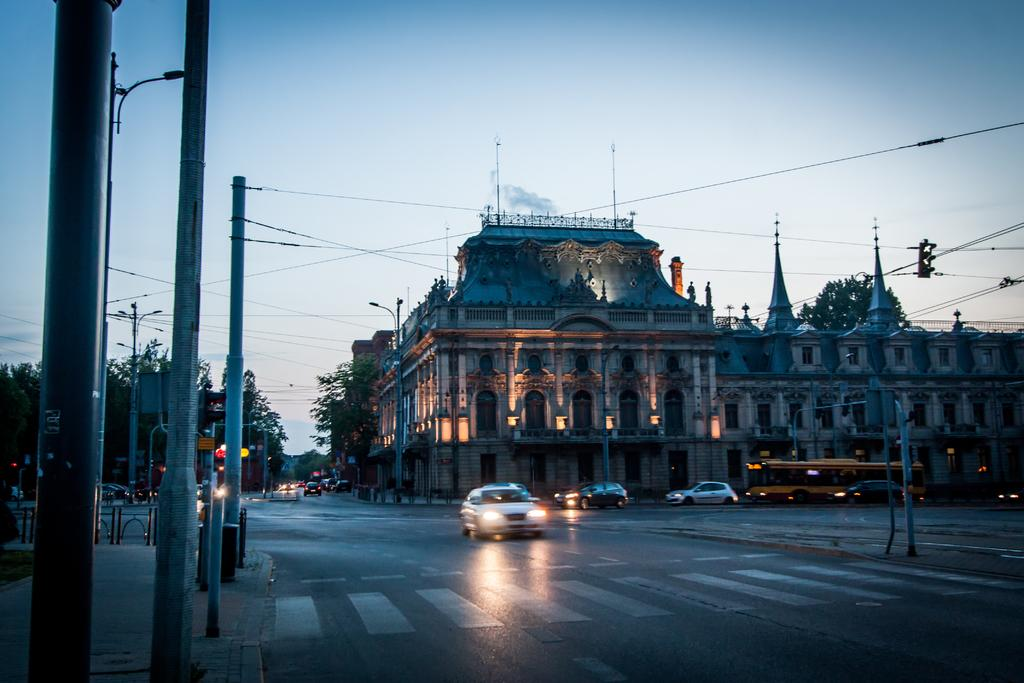What can be seen on the road in the image? There are vehicles on the road in the image. What structures are present in the image? There are buildings in the image. What objects can be seen in the image that are related to infrastructure? There are poles, lights, and wires in the image. What type of natural elements are visible in the image? There are trees in the image. What type of barrier is present in the image? There is a fence in the image. What can be seen in the background of the image? The sky with clouds is visible in the background of the image. What channel is the fence tuned to in the image? There is no channel or television present in the image; it features a fence. What type of badge is the tree wearing in the image? There is no badge present in the image; it features a tree. 